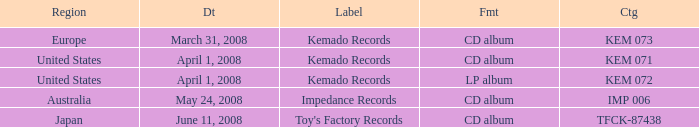Which Label has a Region of united states, and a Format of lp album? Kemado Records. 